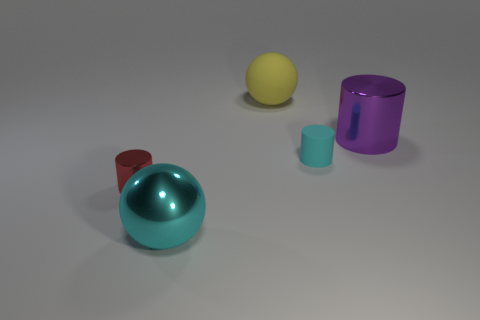Add 4 small metallic things. How many objects exist? 9 Subtract all cylinders. How many objects are left? 2 Add 4 large shiny objects. How many large shiny objects are left? 6 Add 5 blue rubber cubes. How many blue rubber cubes exist? 5 Subtract 0 brown cylinders. How many objects are left? 5 Subtract all tiny objects. Subtract all tiny cyan things. How many objects are left? 2 